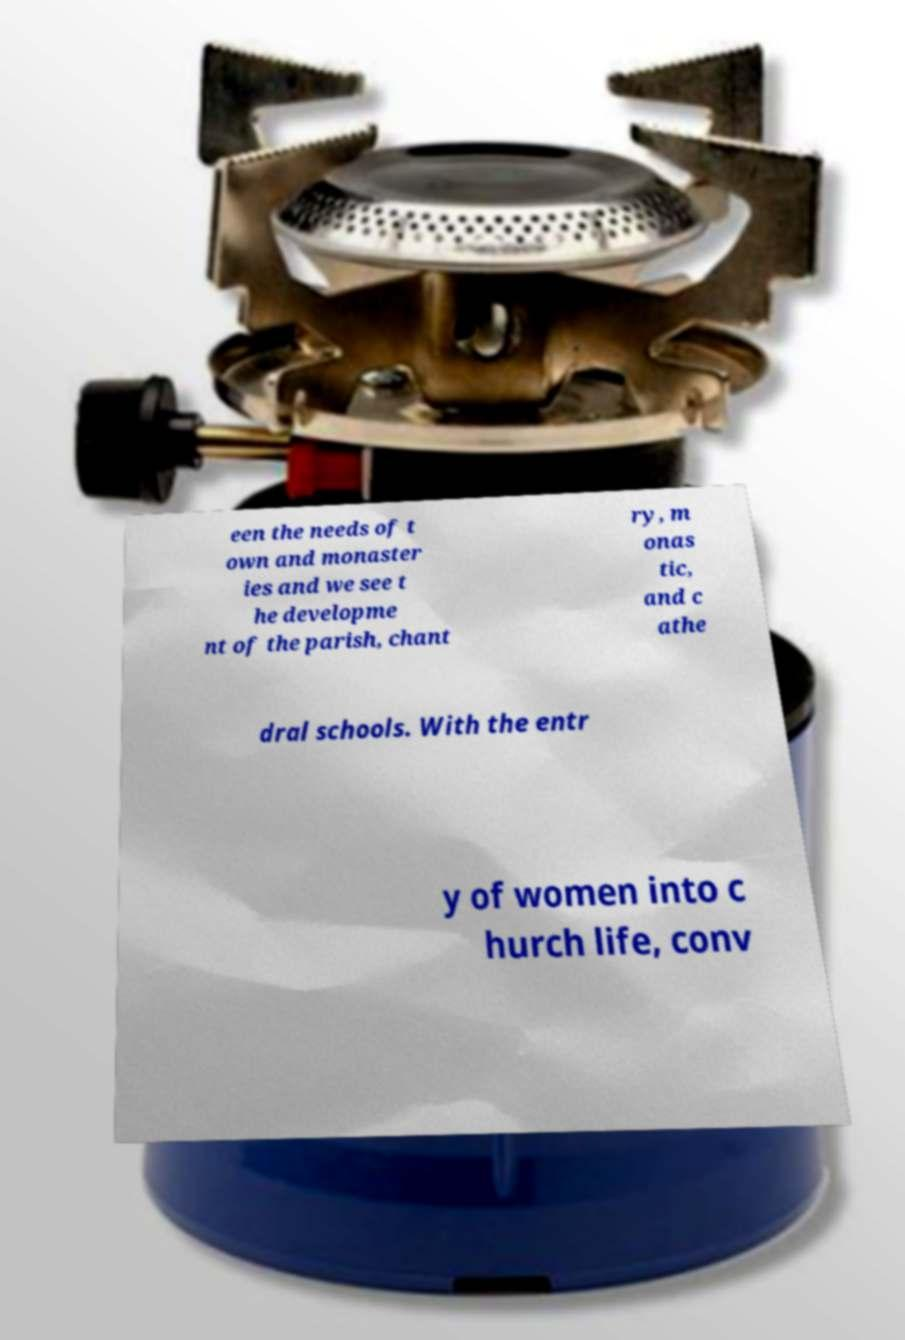What messages or text are displayed in this image? I need them in a readable, typed format. een the needs of t own and monaster ies and we see t he developme nt of the parish, chant ry, m onas tic, and c athe dral schools. With the entr y of women into c hurch life, conv 